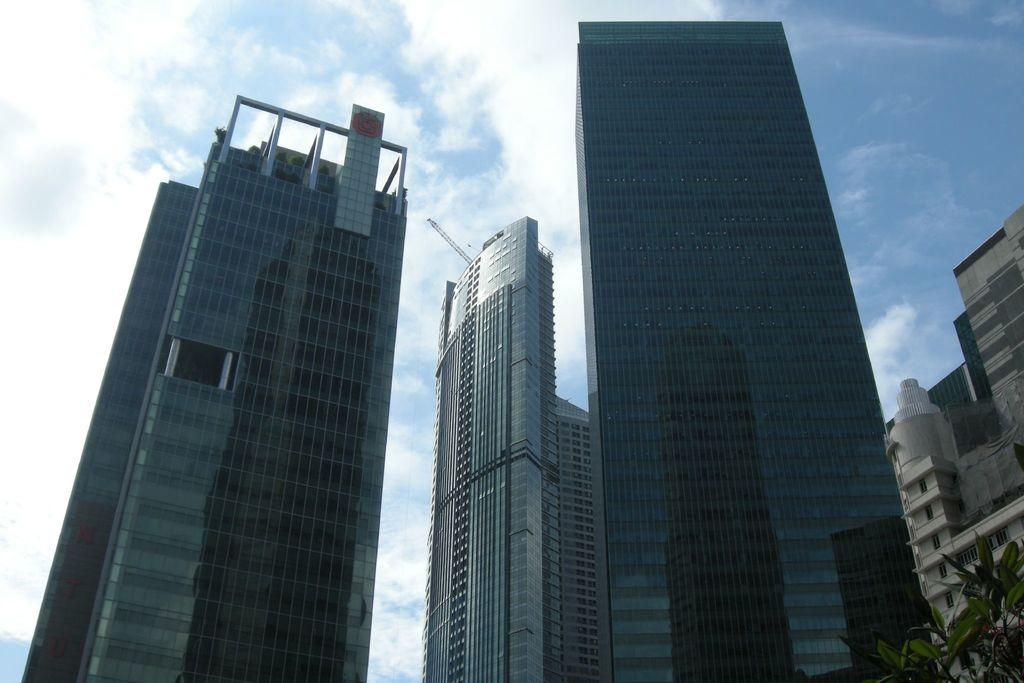What type of structures are present in the image? There are tower buildings in the image. What type of vegetation can be seen in the image? There is a plant in the image. What is the color of the sky in the background? The sky is blue in the background. What can be seen in the sky besides the blue color? Clouds are visible in the sky. How many ducks are holding hands with bears in the image? There are no ducks or bears present in the image. 